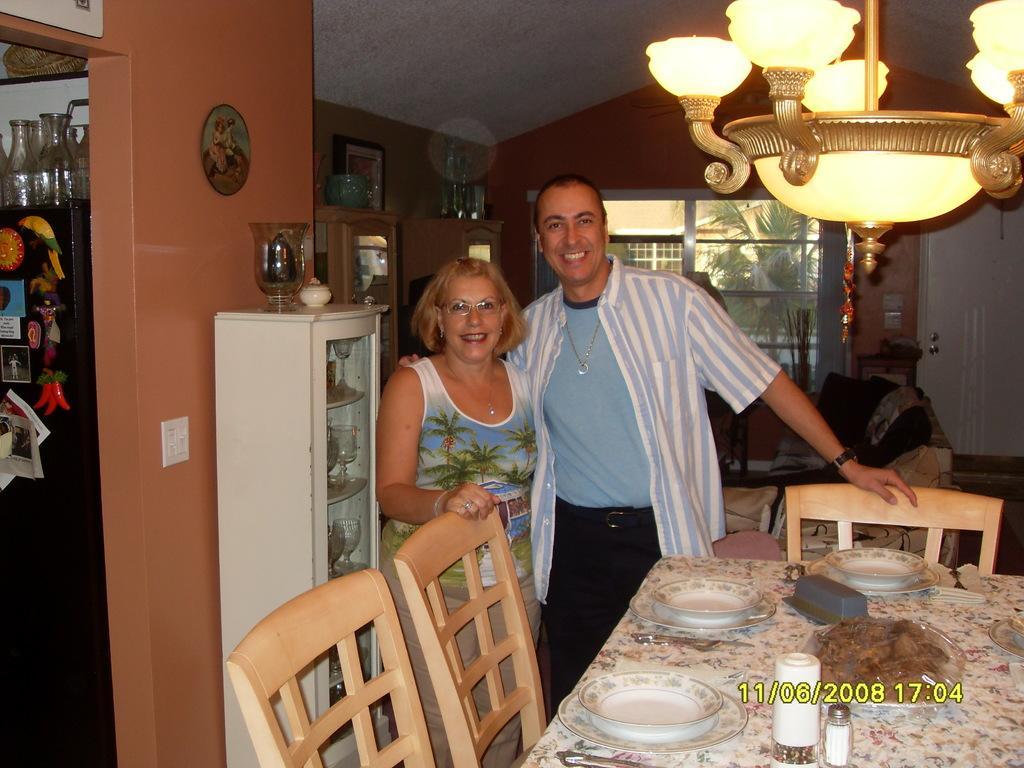Could you give a brief overview of what you see in this image? This picture shows a woman and a man standing with a smile on their faces and we see view plates on the dining table and few chairs and we see a light. 